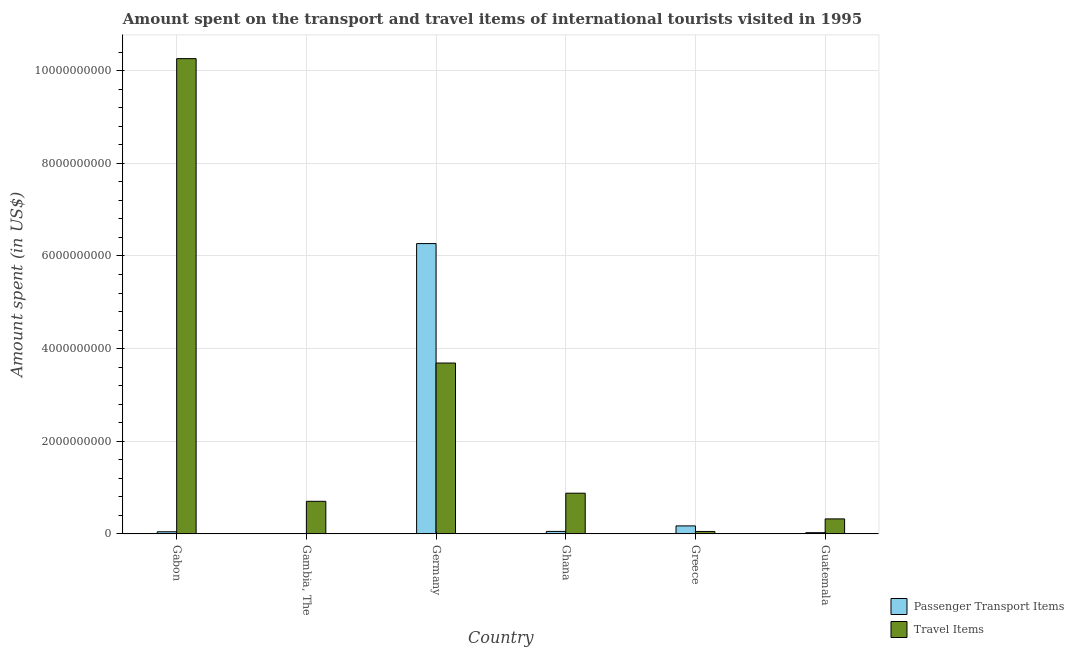How many different coloured bars are there?
Your response must be concise. 2. How many bars are there on the 5th tick from the right?
Offer a terse response. 2. What is the label of the 1st group of bars from the left?
Keep it short and to the point. Gabon. What is the amount spent on passenger transport items in Greece?
Make the answer very short. 1.72e+08. Across all countries, what is the maximum amount spent on passenger transport items?
Your response must be concise. 6.27e+09. In which country was the amount spent on passenger transport items maximum?
Provide a short and direct response. Germany. In which country was the amount spent in travel items minimum?
Keep it short and to the point. Greece. What is the total amount spent in travel items in the graph?
Your response must be concise. 1.59e+1. What is the difference between the amount spent in travel items in Gambia, The and that in Ghana?
Ensure brevity in your answer.  -1.75e+08. What is the difference between the amount spent on passenger transport items in Germany and the amount spent in travel items in Guatemala?
Your answer should be compact. 5.94e+09. What is the average amount spent in travel items per country?
Offer a terse response. 2.65e+09. What is the difference between the amount spent in travel items and amount spent on passenger transport items in Gabon?
Keep it short and to the point. 1.02e+1. In how many countries, is the amount spent on passenger transport items greater than 9600000000 US$?
Ensure brevity in your answer.  0. What is the ratio of the amount spent in travel items in Germany to that in Guatemala?
Your response must be concise. 11.42. What is the difference between the highest and the second highest amount spent in travel items?
Ensure brevity in your answer.  6.57e+09. What is the difference between the highest and the lowest amount spent on passenger transport items?
Make the answer very short. 6.26e+09. In how many countries, is the amount spent on passenger transport items greater than the average amount spent on passenger transport items taken over all countries?
Your answer should be compact. 1. Is the sum of the amount spent on passenger transport items in Ghana and Guatemala greater than the maximum amount spent in travel items across all countries?
Provide a short and direct response. No. What does the 2nd bar from the left in Ghana represents?
Give a very brief answer. Travel Items. What does the 1st bar from the right in Guatemala represents?
Offer a terse response. Travel Items. How many countries are there in the graph?
Provide a short and direct response. 6. Does the graph contain any zero values?
Offer a terse response. No. Does the graph contain grids?
Offer a very short reply. Yes. How many legend labels are there?
Give a very brief answer. 2. How are the legend labels stacked?
Provide a short and direct response. Vertical. What is the title of the graph?
Provide a short and direct response. Amount spent on the transport and travel items of international tourists visited in 1995. Does "constant 2005 US$" appear as one of the legend labels in the graph?
Ensure brevity in your answer.  No. What is the label or title of the X-axis?
Your answer should be very brief. Country. What is the label or title of the Y-axis?
Make the answer very short. Amount spent (in US$). What is the Amount spent (in US$) of Passenger Transport Items in Gabon?
Your answer should be compact. 4.50e+07. What is the Amount spent (in US$) of Travel Items in Gabon?
Your answer should be very brief. 1.03e+1. What is the Amount spent (in US$) of Passenger Transport Items in Gambia, The?
Provide a short and direct response. 2.00e+06. What is the Amount spent (in US$) of Travel Items in Gambia, The?
Make the answer very short. 7.03e+08. What is the Amount spent (in US$) in Passenger Transport Items in Germany?
Keep it short and to the point. 6.27e+09. What is the Amount spent (in US$) in Travel Items in Germany?
Make the answer very short. 3.69e+09. What is the Amount spent (in US$) in Passenger Transport Items in Ghana?
Provide a succinct answer. 5.30e+07. What is the Amount spent (in US$) of Travel Items in Ghana?
Your answer should be compact. 8.78e+08. What is the Amount spent (in US$) of Passenger Transport Items in Greece?
Provide a succinct answer. 1.72e+08. What is the Amount spent (in US$) in Travel Items in Greece?
Offer a terse response. 5.20e+07. What is the Amount spent (in US$) of Passenger Transport Items in Guatemala?
Ensure brevity in your answer.  2.60e+07. What is the Amount spent (in US$) in Travel Items in Guatemala?
Offer a terse response. 3.23e+08. Across all countries, what is the maximum Amount spent (in US$) in Passenger Transport Items?
Offer a very short reply. 6.27e+09. Across all countries, what is the maximum Amount spent (in US$) in Travel Items?
Offer a very short reply. 1.03e+1. Across all countries, what is the minimum Amount spent (in US$) in Passenger Transport Items?
Your response must be concise. 2.00e+06. Across all countries, what is the minimum Amount spent (in US$) in Travel Items?
Keep it short and to the point. 5.20e+07. What is the total Amount spent (in US$) of Passenger Transport Items in the graph?
Your answer should be very brief. 6.56e+09. What is the total Amount spent (in US$) of Travel Items in the graph?
Offer a terse response. 1.59e+1. What is the difference between the Amount spent (in US$) in Passenger Transport Items in Gabon and that in Gambia, The?
Your answer should be compact. 4.30e+07. What is the difference between the Amount spent (in US$) of Travel Items in Gabon and that in Gambia, The?
Offer a terse response. 9.56e+09. What is the difference between the Amount spent (in US$) in Passenger Transport Items in Gabon and that in Germany?
Give a very brief answer. -6.22e+09. What is the difference between the Amount spent (in US$) in Travel Items in Gabon and that in Germany?
Make the answer very short. 6.57e+09. What is the difference between the Amount spent (in US$) of Passenger Transport Items in Gabon and that in Ghana?
Your answer should be very brief. -8.00e+06. What is the difference between the Amount spent (in US$) in Travel Items in Gabon and that in Ghana?
Offer a very short reply. 9.38e+09. What is the difference between the Amount spent (in US$) of Passenger Transport Items in Gabon and that in Greece?
Keep it short and to the point. -1.27e+08. What is the difference between the Amount spent (in US$) of Travel Items in Gabon and that in Greece?
Offer a terse response. 1.02e+1. What is the difference between the Amount spent (in US$) in Passenger Transport Items in Gabon and that in Guatemala?
Offer a very short reply. 1.90e+07. What is the difference between the Amount spent (in US$) of Travel Items in Gabon and that in Guatemala?
Your answer should be compact. 9.94e+09. What is the difference between the Amount spent (in US$) of Passenger Transport Items in Gambia, The and that in Germany?
Your answer should be very brief. -6.26e+09. What is the difference between the Amount spent (in US$) in Travel Items in Gambia, The and that in Germany?
Offer a very short reply. -2.98e+09. What is the difference between the Amount spent (in US$) of Passenger Transport Items in Gambia, The and that in Ghana?
Make the answer very short. -5.10e+07. What is the difference between the Amount spent (in US$) in Travel Items in Gambia, The and that in Ghana?
Ensure brevity in your answer.  -1.75e+08. What is the difference between the Amount spent (in US$) of Passenger Transport Items in Gambia, The and that in Greece?
Make the answer very short. -1.70e+08. What is the difference between the Amount spent (in US$) of Travel Items in Gambia, The and that in Greece?
Ensure brevity in your answer.  6.51e+08. What is the difference between the Amount spent (in US$) of Passenger Transport Items in Gambia, The and that in Guatemala?
Your response must be concise. -2.40e+07. What is the difference between the Amount spent (in US$) of Travel Items in Gambia, The and that in Guatemala?
Your answer should be compact. 3.80e+08. What is the difference between the Amount spent (in US$) of Passenger Transport Items in Germany and that in Ghana?
Your answer should be very brief. 6.21e+09. What is the difference between the Amount spent (in US$) of Travel Items in Germany and that in Ghana?
Your response must be concise. 2.81e+09. What is the difference between the Amount spent (in US$) of Passenger Transport Items in Germany and that in Greece?
Keep it short and to the point. 6.10e+09. What is the difference between the Amount spent (in US$) of Travel Items in Germany and that in Greece?
Provide a short and direct response. 3.64e+09. What is the difference between the Amount spent (in US$) of Passenger Transport Items in Germany and that in Guatemala?
Provide a succinct answer. 6.24e+09. What is the difference between the Amount spent (in US$) in Travel Items in Germany and that in Guatemala?
Make the answer very short. 3.36e+09. What is the difference between the Amount spent (in US$) of Passenger Transport Items in Ghana and that in Greece?
Make the answer very short. -1.19e+08. What is the difference between the Amount spent (in US$) of Travel Items in Ghana and that in Greece?
Your answer should be very brief. 8.26e+08. What is the difference between the Amount spent (in US$) of Passenger Transport Items in Ghana and that in Guatemala?
Give a very brief answer. 2.70e+07. What is the difference between the Amount spent (in US$) in Travel Items in Ghana and that in Guatemala?
Keep it short and to the point. 5.55e+08. What is the difference between the Amount spent (in US$) in Passenger Transport Items in Greece and that in Guatemala?
Your answer should be very brief. 1.46e+08. What is the difference between the Amount spent (in US$) of Travel Items in Greece and that in Guatemala?
Ensure brevity in your answer.  -2.71e+08. What is the difference between the Amount spent (in US$) in Passenger Transport Items in Gabon and the Amount spent (in US$) in Travel Items in Gambia, The?
Your response must be concise. -6.58e+08. What is the difference between the Amount spent (in US$) of Passenger Transport Items in Gabon and the Amount spent (in US$) of Travel Items in Germany?
Keep it short and to the point. -3.64e+09. What is the difference between the Amount spent (in US$) of Passenger Transport Items in Gabon and the Amount spent (in US$) of Travel Items in Ghana?
Provide a succinct answer. -8.33e+08. What is the difference between the Amount spent (in US$) of Passenger Transport Items in Gabon and the Amount spent (in US$) of Travel Items in Greece?
Offer a very short reply. -7.00e+06. What is the difference between the Amount spent (in US$) in Passenger Transport Items in Gabon and the Amount spent (in US$) in Travel Items in Guatemala?
Give a very brief answer. -2.78e+08. What is the difference between the Amount spent (in US$) in Passenger Transport Items in Gambia, The and the Amount spent (in US$) in Travel Items in Germany?
Ensure brevity in your answer.  -3.69e+09. What is the difference between the Amount spent (in US$) in Passenger Transport Items in Gambia, The and the Amount spent (in US$) in Travel Items in Ghana?
Make the answer very short. -8.76e+08. What is the difference between the Amount spent (in US$) in Passenger Transport Items in Gambia, The and the Amount spent (in US$) in Travel Items in Greece?
Ensure brevity in your answer.  -5.00e+07. What is the difference between the Amount spent (in US$) in Passenger Transport Items in Gambia, The and the Amount spent (in US$) in Travel Items in Guatemala?
Provide a succinct answer. -3.21e+08. What is the difference between the Amount spent (in US$) in Passenger Transport Items in Germany and the Amount spent (in US$) in Travel Items in Ghana?
Ensure brevity in your answer.  5.39e+09. What is the difference between the Amount spent (in US$) in Passenger Transport Items in Germany and the Amount spent (in US$) in Travel Items in Greece?
Keep it short and to the point. 6.22e+09. What is the difference between the Amount spent (in US$) of Passenger Transport Items in Germany and the Amount spent (in US$) of Travel Items in Guatemala?
Your answer should be very brief. 5.94e+09. What is the difference between the Amount spent (in US$) in Passenger Transport Items in Ghana and the Amount spent (in US$) in Travel Items in Guatemala?
Make the answer very short. -2.70e+08. What is the difference between the Amount spent (in US$) in Passenger Transport Items in Greece and the Amount spent (in US$) in Travel Items in Guatemala?
Make the answer very short. -1.51e+08. What is the average Amount spent (in US$) of Passenger Transport Items per country?
Give a very brief answer. 1.09e+09. What is the average Amount spent (in US$) in Travel Items per country?
Offer a terse response. 2.65e+09. What is the difference between the Amount spent (in US$) of Passenger Transport Items and Amount spent (in US$) of Travel Items in Gabon?
Make the answer very short. -1.02e+1. What is the difference between the Amount spent (in US$) in Passenger Transport Items and Amount spent (in US$) in Travel Items in Gambia, The?
Your answer should be very brief. -7.01e+08. What is the difference between the Amount spent (in US$) of Passenger Transport Items and Amount spent (in US$) of Travel Items in Germany?
Offer a very short reply. 2.58e+09. What is the difference between the Amount spent (in US$) in Passenger Transport Items and Amount spent (in US$) in Travel Items in Ghana?
Provide a succinct answer. -8.25e+08. What is the difference between the Amount spent (in US$) of Passenger Transport Items and Amount spent (in US$) of Travel Items in Greece?
Offer a very short reply. 1.20e+08. What is the difference between the Amount spent (in US$) of Passenger Transport Items and Amount spent (in US$) of Travel Items in Guatemala?
Offer a very short reply. -2.97e+08. What is the ratio of the Amount spent (in US$) of Passenger Transport Items in Gabon to that in Gambia, The?
Provide a succinct answer. 22.5. What is the ratio of the Amount spent (in US$) in Travel Items in Gabon to that in Gambia, The?
Keep it short and to the point. 14.59. What is the ratio of the Amount spent (in US$) of Passenger Transport Items in Gabon to that in Germany?
Offer a very short reply. 0.01. What is the ratio of the Amount spent (in US$) of Travel Items in Gabon to that in Germany?
Ensure brevity in your answer.  2.78. What is the ratio of the Amount spent (in US$) in Passenger Transport Items in Gabon to that in Ghana?
Your answer should be compact. 0.85. What is the ratio of the Amount spent (in US$) in Travel Items in Gabon to that in Ghana?
Make the answer very short. 11.69. What is the ratio of the Amount spent (in US$) in Passenger Transport Items in Gabon to that in Greece?
Give a very brief answer. 0.26. What is the ratio of the Amount spent (in US$) of Travel Items in Gabon to that in Greece?
Provide a short and direct response. 197.31. What is the ratio of the Amount spent (in US$) of Passenger Transport Items in Gabon to that in Guatemala?
Your answer should be compact. 1.73. What is the ratio of the Amount spent (in US$) in Travel Items in Gabon to that in Guatemala?
Provide a short and direct response. 31.76. What is the ratio of the Amount spent (in US$) in Passenger Transport Items in Gambia, The to that in Germany?
Give a very brief answer. 0. What is the ratio of the Amount spent (in US$) in Travel Items in Gambia, The to that in Germany?
Give a very brief answer. 0.19. What is the ratio of the Amount spent (in US$) of Passenger Transport Items in Gambia, The to that in Ghana?
Keep it short and to the point. 0.04. What is the ratio of the Amount spent (in US$) in Travel Items in Gambia, The to that in Ghana?
Provide a short and direct response. 0.8. What is the ratio of the Amount spent (in US$) in Passenger Transport Items in Gambia, The to that in Greece?
Provide a succinct answer. 0.01. What is the ratio of the Amount spent (in US$) of Travel Items in Gambia, The to that in Greece?
Your answer should be very brief. 13.52. What is the ratio of the Amount spent (in US$) of Passenger Transport Items in Gambia, The to that in Guatemala?
Keep it short and to the point. 0.08. What is the ratio of the Amount spent (in US$) in Travel Items in Gambia, The to that in Guatemala?
Provide a short and direct response. 2.18. What is the ratio of the Amount spent (in US$) in Passenger Transport Items in Germany to that in Ghana?
Keep it short and to the point. 118.25. What is the ratio of the Amount spent (in US$) of Travel Items in Germany to that in Ghana?
Provide a short and direct response. 4.2. What is the ratio of the Amount spent (in US$) in Passenger Transport Items in Germany to that in Greece?
Provide a short and direct response. 36.44. What is the ratio of the Amount spent (in US$) in Travel Items in Germany to that in Greece?
Make the answer very short. 70.92. What is the ratio of the Amount spent (in US$) in Passenger Transport Items in Germany to that in Guatemala?
Your answer should be very brief. 241.04. What is the ratio of the Amount spent (in US$) in Travel Items in Germany to that in Guatemala?
Your answer should be very brief. 11.42. What is the ratio of the Amount spent (in US$) in Passenger Transport Items in Ghana to that in Greece?
Provide a succinct answer. 0.31. What is the ratio of the Amount spent (in US$) in Travel Items in Ghana to that in Greece?
Provide a succinct answer. 16.88. What is the ratio of the Amount spent (in US$) in Passenger Transport Items in Ghana to that in Guatemala?
Your response must be concise. 2.04. What is the ratio of the Amount spent (in US$) in Travel Items in Ghana to that in Guatemala?
Give a very brief answer. 2.72. What is the ratio of the Amount spent (in US$) in Passenger Transport Items in Greece to that in Guatemala?
Provide a short and direct response. 6.62. What is the ratio of the Amount spent (in US$) of Travel Items in Greece to that in Guatemala?
Keep it short and to the point. 0.16. What is the difference between the highest and the second highest Amount spent (in US$) of Passenger Transport Items?
Provide a succinct answer. 6.10e+09. What is the difference between the highest and the second highest Amount spent (in US$) in Travel Items?
Your answer should be very brief. 6.57e+09. What is the difference between the highest and the lowest Amount spent (in US$) of Passenger Transport Items?
Offer a terse response. 6.26e+09. What is the difference between the highest and the lowest Amount spent (in US$) of Travel Items?
Your answer should be very brief. 1.02e+1. 